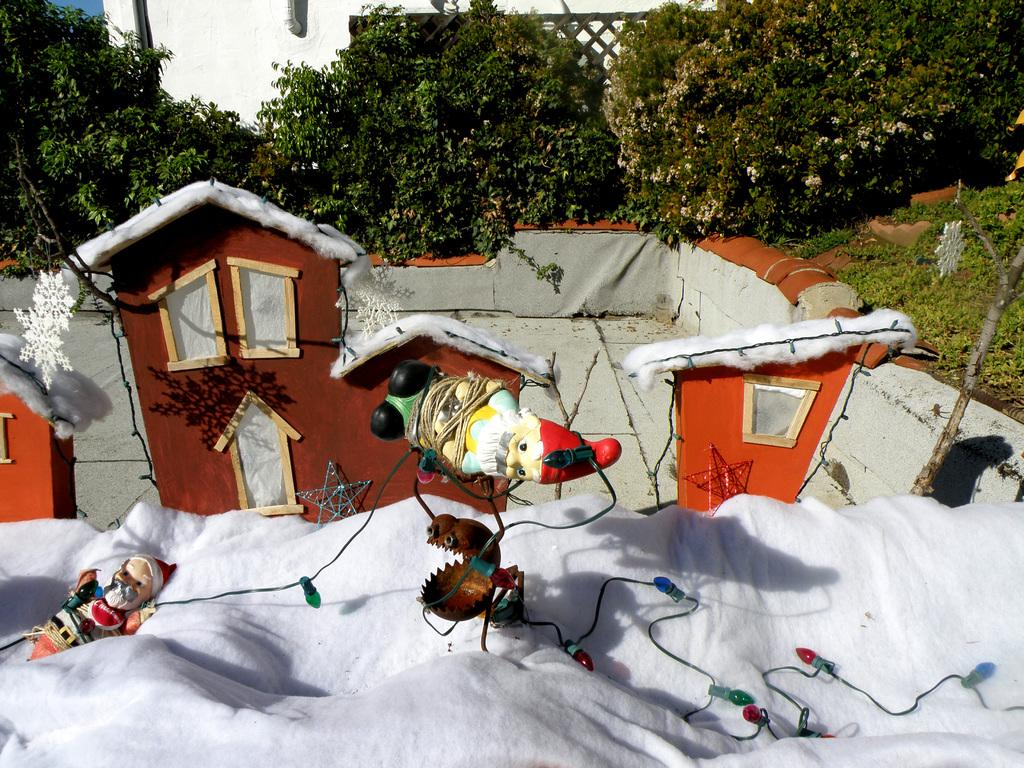What is located in the foreground of the image? There is a home and toys in the foreground of the image. What else can be seen in the foreground of the image? Decorations are present in the foreground of the image. What is visible in the background of the image? There are trees and a building in the background of the image. Can you describe the harmony between the giants and the tin in the image? There are no giants or tin present in the image, so it is not possible to describe any harmony between them. 